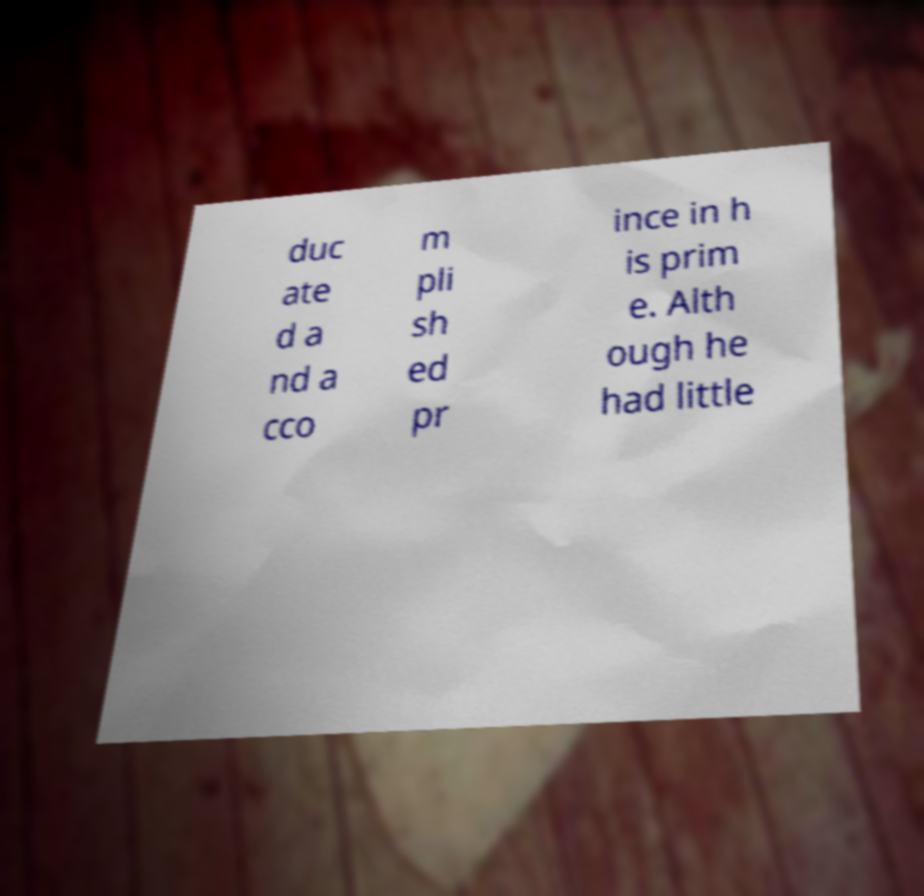Please identify and transcribe the text found in this image. duc ate d a nd a cco m pli sh ed pr ince in h is prim e. Alth ough he had little 